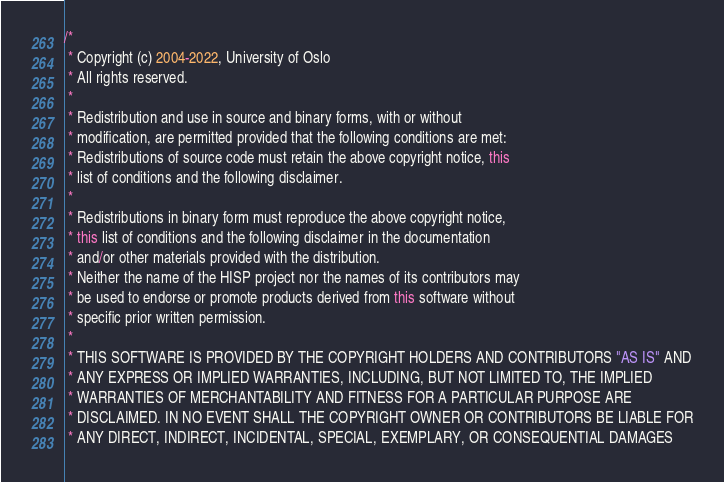Convert code to text. <code><loc_0><loc_0><loc_500><loc_500><_Java_>/*
 * Copyright (c) 2004-2022, University of Oslo
 * All rights reserved.
 *
 * Redistribution and use in source and binary forms, with or without
 * modification, are permitted provided that the following conditions are met:
 * Redistributions of source code must retain the above copyright notice, this
 * list of conditions and the following disclaimer.
 *
 * Redistributions in binary form must reproduce the above copyright notice,
 * this list of conditions and the following disclaimer in the documentation
 * and/or other materials provided with the distribution.
 * Neither the name of the HISP project nor the names of its contributors may
 * be used to endorse or promote products derived from this software without
 * specific prior written permission.
 *
 * THIS SOFTWARE IS PROVIDED BY THE COPYRIGHT HOLDERS AND CONTRIBUTORS "AS IS" AND
 * ANY EXPRESS OR IMPLIED WARRANTIES, INCLUDING, BUT NOT LIMITED TO, THE IMPLIED
 * WARRANTIES OF MERCHANTABILITY AND FITNESS FOR A PARTICULAR PURPOSE ARE
 * DISCLAIMED. IN NO EVENT SHALL THE COPYRIGHT OWNER OR CONTRIBUTORS BE LIABLE FOR
 * ANY DIRECT, INDIRECT, INCIDENTAL, SPECIAL, EXEMPLARY, OR CONSEQUENTIAL DAMAGES</code> 